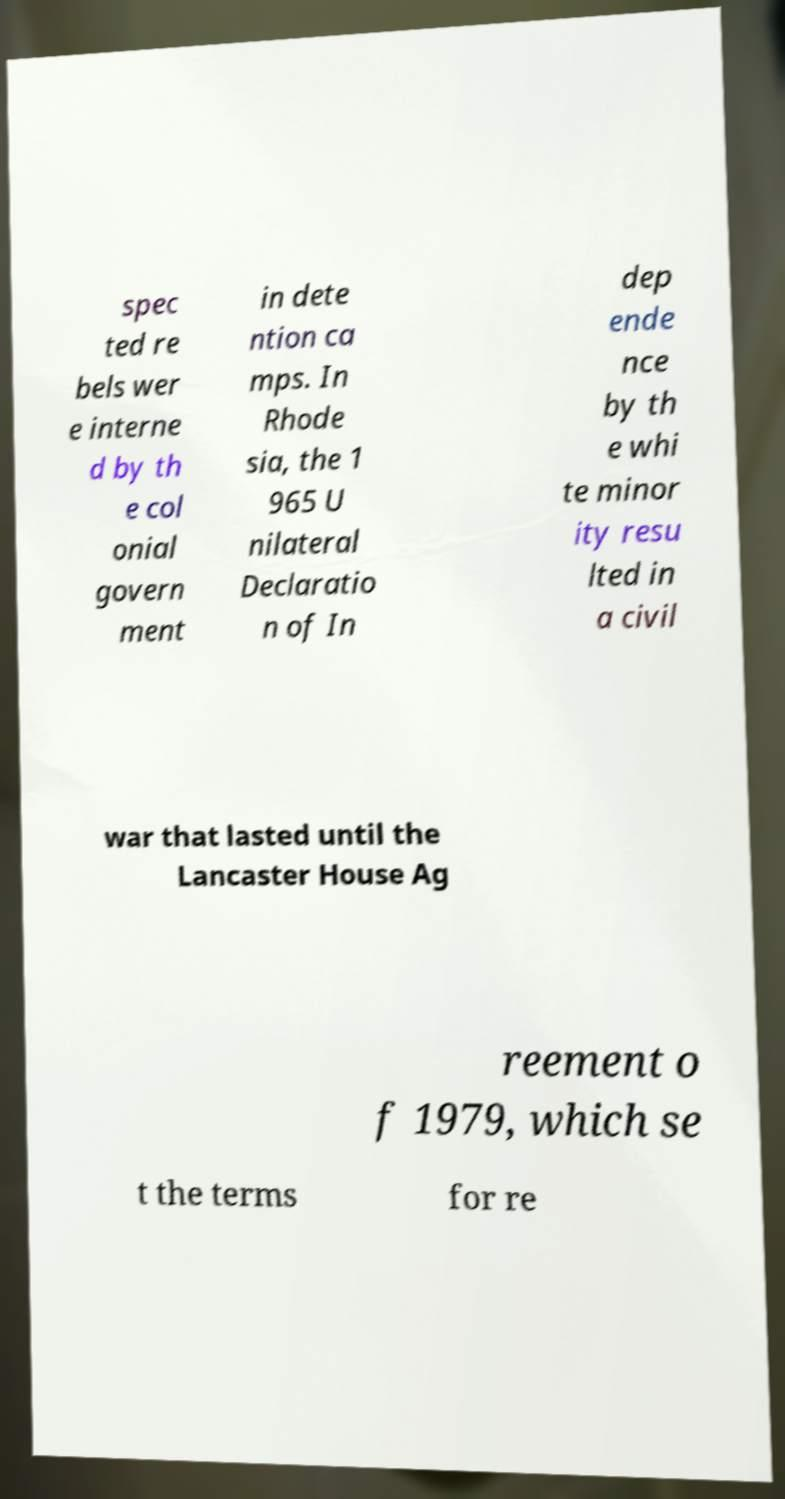What messages or text are displayed in this image? I need them in a readable, typed format. spec ted re bels wer e interne d by th e col onial govern ment in dete ntion ca mps. In Rhode sia, the 1 965 U nilateral Declaratio n of In dep ende nce by th e whi te minor ity resu lted in a civil war that lasted until the Lancaster House Ag reement o f 1979, which se t the terms for re 